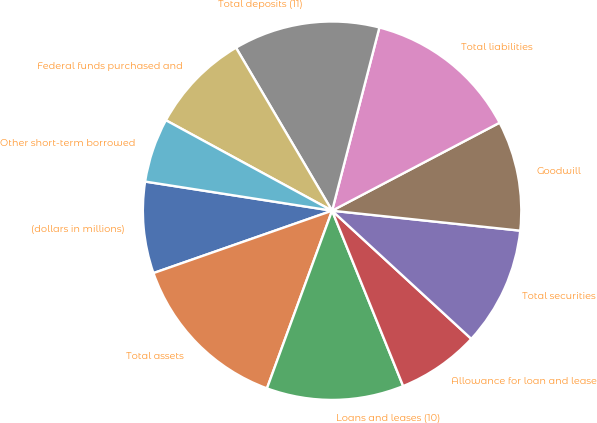Convert chart to OTSL. <chart><loc_0><loc_0><loc_500><loc_500><pie_chart><fcel>(dollars in millions)<fcel>Total assets<fcel>Loans and leases (10)<fcel>Allowance for loan and lease<fcel>Total securities<fcel>Goodwill<fcel>Total liabilities<fcel>Total deposits (11)<fcel>Federal funds purchased and<fcel>Other short-term borrowed<nl><fcel>7.81%<fcel>14.06%<fcel>11.72%<fcel>7.03%<fcel>10.16%<fcel>9.38%<fcel>13.28%<fcel>12.5%<fcel>8.59%<fcel>5.47%<nl></chart> 